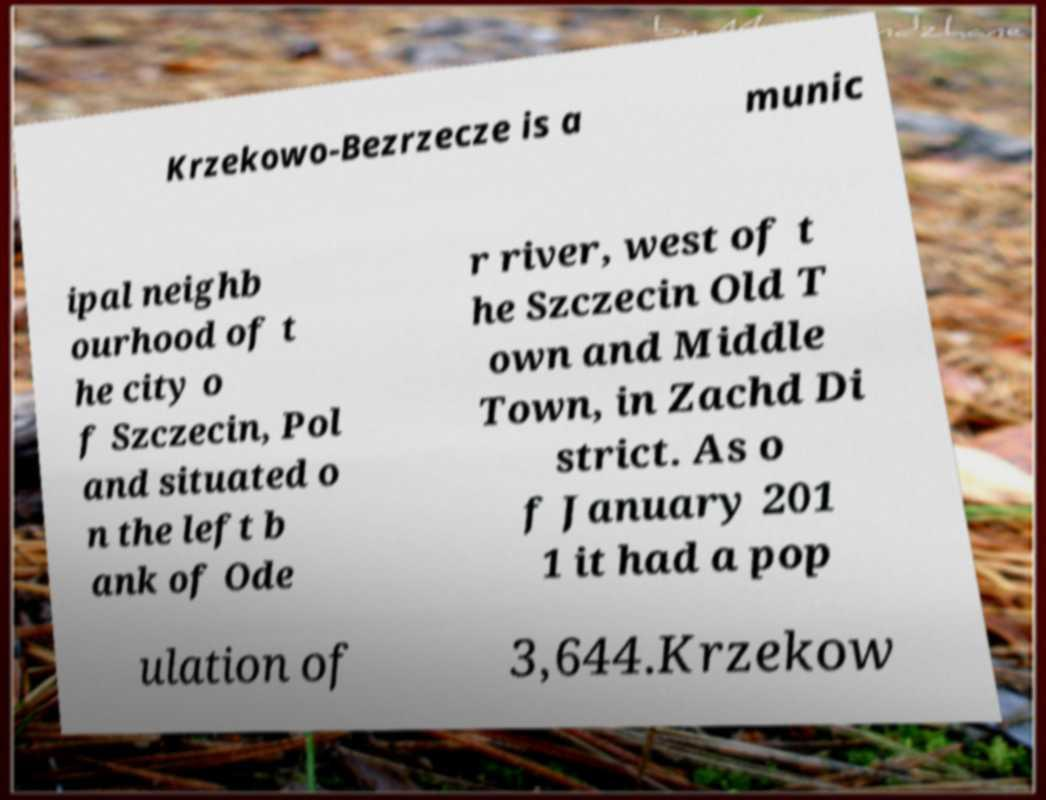Please identify and transcribe the text found in this image. Krzekowo-Bezrzecze is a munic ipal neighb ourhood of t he city o f Szczecin, Pol and situated o n the left b ank of Ode r river, west of t he Szczecin Old T own and Middle Town, in Zachd Di strict. As o f January 201 1 it had a pop ulation of 3,644.Krzekow 